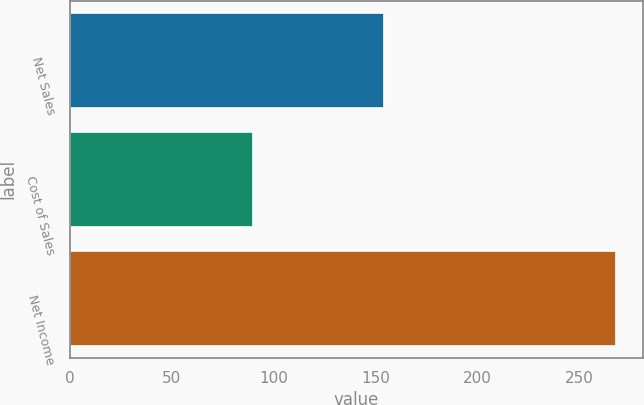Convert chart. <chart><loc_0><loc_0><loc_500><loc_500><bar_chart><fcel>Net Sales<fcel>Cost of Sales<fcel>Net Income<nl><fcel>154<fcel>90<fcel>268<nl></chart> 